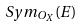Convert formula to latex. <formula><loc_0><loc_0><loc_500><loc_500>S y m _ { O _ { X } } ( E )</formula> 